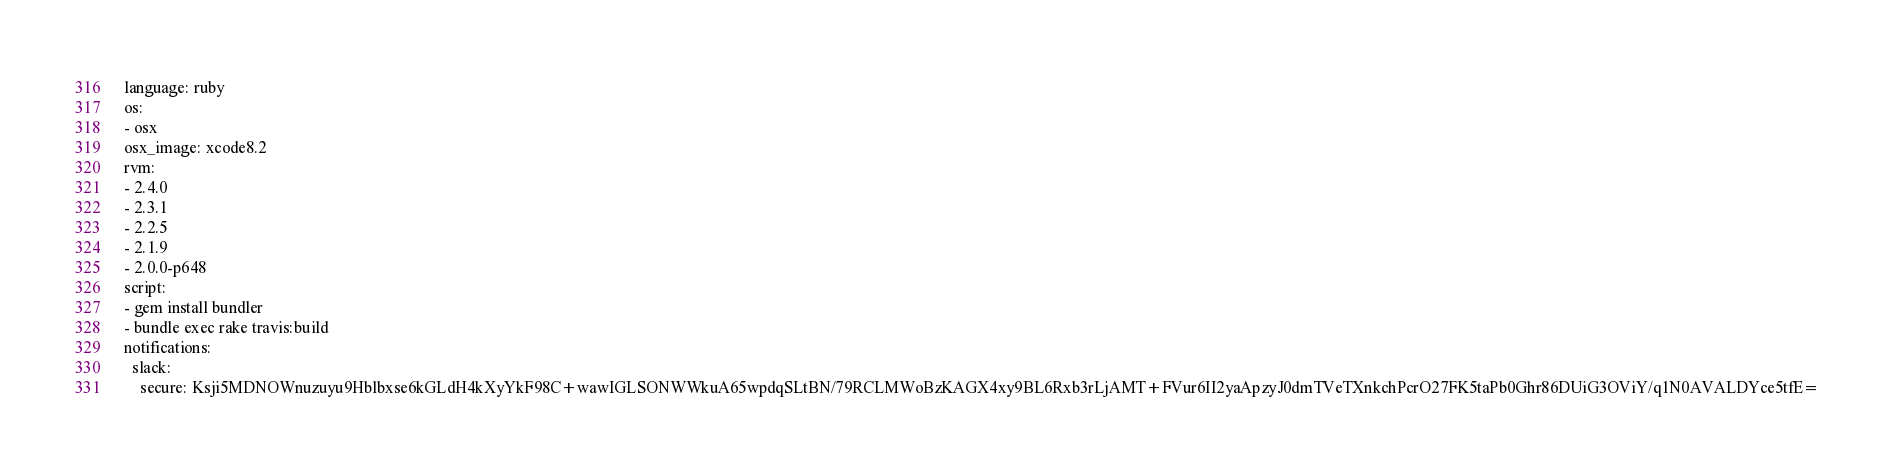Convert code to text. <code><loc_0><loc_0><loc_500><loc_500><_YAML_>language: ruby
os:
- osx
osx_image: xcode8.2
rvm:
- 2.4.0
- 2.3.1
- 2.2.5
- 2.1.9
- 2.0.0-p648
script:
- gem install bundler
- bundle exec rake travis:build
notifications:
  slack:
    secure: Ksji5MDNOWnuzuyu9Hblbxse6kGLdH4kXyYkF98C+wawIGLSONWWkuA65wpdqSLtBN/79RCLMWoBzKAGX4xy9BL6Rxb3rLjAMT+FVur6II2yaApzyJ0dmTVeTXnkchPcrO27FK5taPb0Ghr86DUiG3OViY/q1N0AVALDYce5tfE=
</code> 